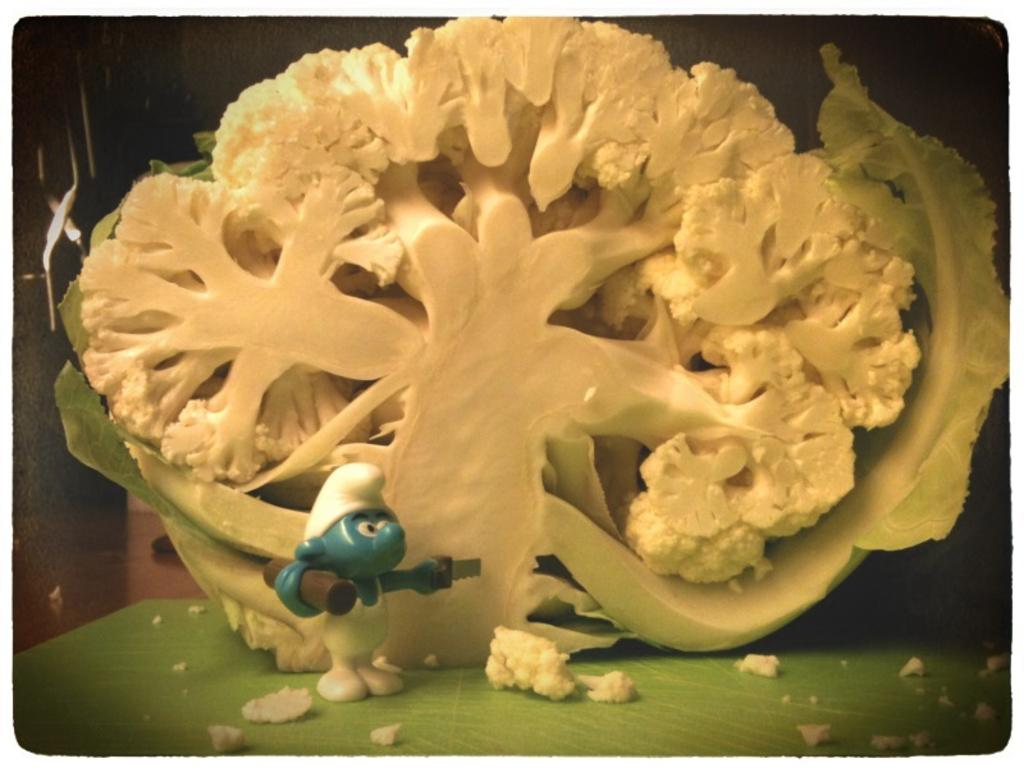What color is the vegetable in the image? The vegetable in the image is white-colored. What other object can be seen in the image besides the vegetable? There is a small plastic toy in the image. What range of emotions does the vegetable express in the image? Vegetables do not express emotions, so this question cannot be answered. 